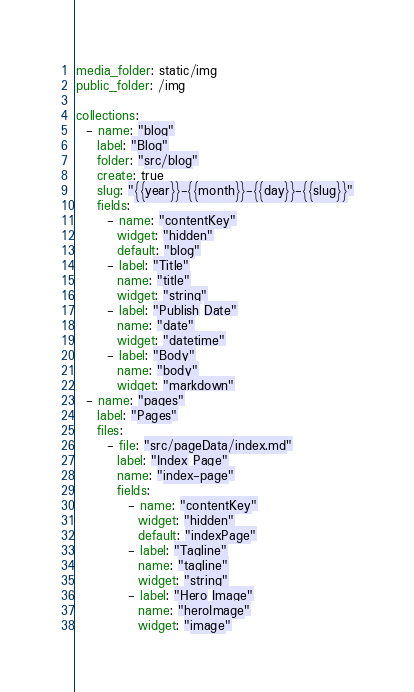<code> <loc_0><loc_0><loc_500><loc_500><_YAML_>media_folder: static/img
public_folder: /img

collections:
  - name: "blog"
    label: "Blog"
    folder: "src/blog"
    create: true
    slug: "{{year}}-{{month}}-{{day}}-{{slug}}"
    fields:
      - name: "contentKey"
        widget: "hidden"
        default: "blog"
      - label: "Title"
        name: "title"
        widget: "string"
      - label: "Publish Date"
        name: "date"
        widget: "datetime"
      - label: "Body"
        name: "body"
        widget: "markdown" 
  - name: "pages"
    label: "Pages"
    files:
      - file: "src/pageData/index.md"
        label: "Index Page"
        name: "index-page"
        fields:
          - name: "contentKey"
            widget: "hidden"
            default: "indexPage"
          - label: "Tagline"
            name: "tagline"
            widget: "string"
          - label: "Hero Image"
            name: "heroImage"
            widget: "image"
</code> 